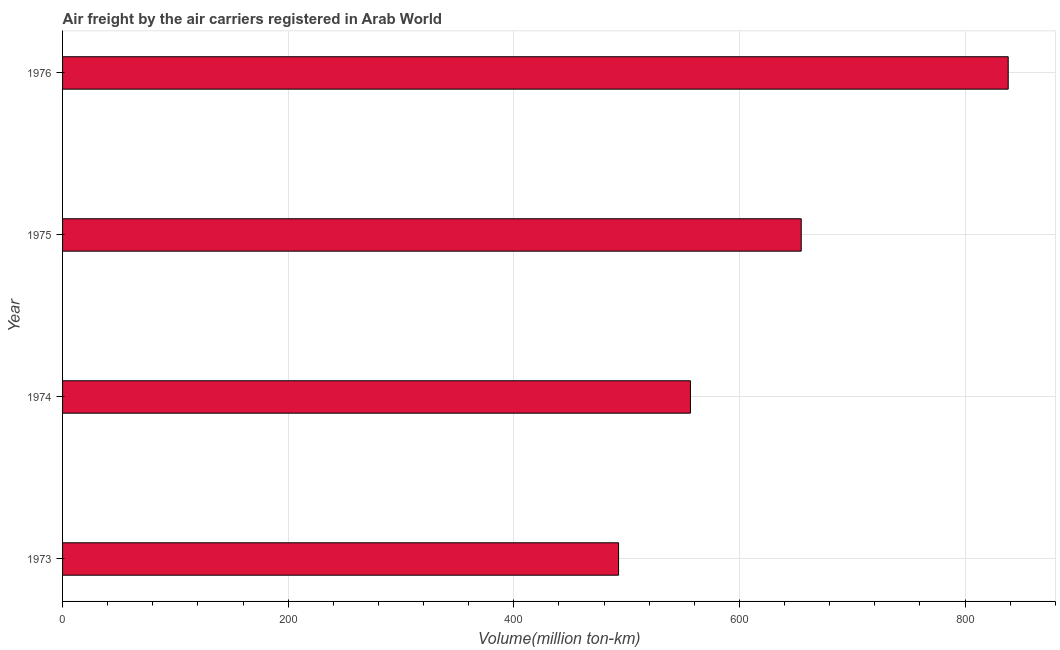Does the graph contain any zero values?
Your answer should be compact. No. What is the title of the graph?
Your answer should be very brief. Air freight by the air carriers registered in Arab World. What is the label or title of the X-axis?
Your response must be concise. Volume(million ton-km). What is the air freight in 1975?
Provide a succinct answer. 654.8. Across all years, what is the maximum air freight?
Your answer should be compact. 838.3. Across all years, what is the minimum air freight?
Make the answer very short. 492.9. In which year was the air freight maximum?
Keep it short and to the point. 1976. What is the sum of the air freight?
Offer a very short reply. 2542.6. What is the difference between the air freight in 1974 and 1975?
Offer a very short reply. -98.2. What is the average air freight per year?
Make the answer very short. 635.65. What is the median air freight?
Keep it short and to the point. 605.7. Do a majority of the years between 1975 and 1974 (inclusive) have air freight greater than 400 million ton-km?
Keep it short and to the point. No. What is the ratio of the air freight in 1973 to that in 1975?
Your answer should be compact. 0.75. What is the difference between the highest and the second highest air freight?
Offer a very short reply. 183.5. What is the difference between the highest and the lowest air freight?
Offer a very short reply. 345.4. How many bars are there?
Ensure brevity in your answer.  4. How many years are there in the graph?
Offer a very short reply. 4. What is the Volume(million ton-km) of 1973?
Your response must be concise. 492.9. What is the Volume(million ton-km) of 1974?
Your answer should be compact. 556.6. What is the Volume(million ton-km) of 1975?
Offer a very short reply. 654.8. What is the Volume(million ton-km) in 1976?
Keep it short and to the point. 838.3. What is the difference between the Volume(million ton-km) in 1973 and 1974?
Ensure brevity in your answer.  -63.7. What is the difference between the Volume(million ton-km) in 1973 and 1975?
Your answer should be compact. -161.9. What is the difference between the Volume(million ton-km) in 1973 and 1976?
Your response must be concise. -345.4. What is the difference between the Volume(million ton-km) in 1974 and 1975?
Offer a very short reply. -98.2. What is the difference between the Volume(million ton-km) in 1974 and 1976?
Offer a terse response. -281.7. What is the difference between the Volume(million ton-km) in 1975 and 1976?
Keep it short and to the point. -183.5. What is the ratio of the Volume(million ton-km) in 1973 to that in 1974?
Give a very brief answer. 0.89. What is the ratio of the Volume(million ton-km) in 1973 to that in 1975?
Your response must be concise. 0.75. What is the ratio of the Volume(million ton-km) in 1973 to that in 1976?
Keep it short and to the point. 0.59. What is the ratio of the Volume(million ton-km) in 1974 to that in 1976?
Offer a very short reply. 0.66. What is the ratio of the Volume(million ton-km) in 1975 to that in 1976?
Make the answer very short. 0.78. 